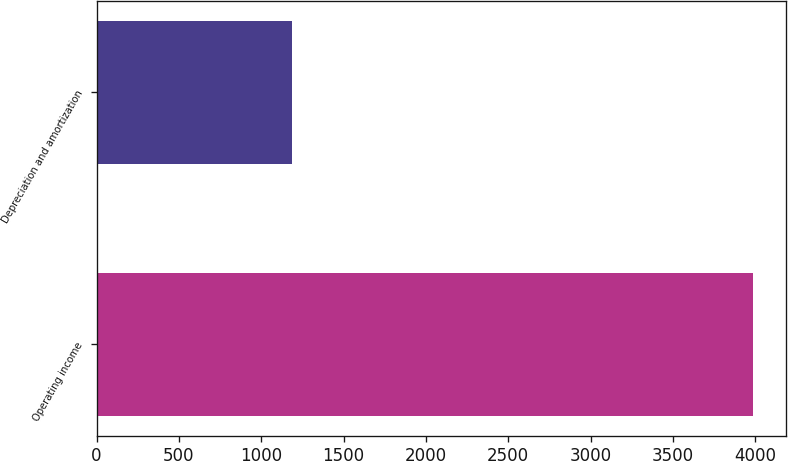Convert chart. <chart><loc_0><loc_0><loc_500><loc_500><bar_chart><fcel>Operating income<fcel>Depreciation and amortization<nl><fcel>3984<fcel>1187.6<nl></chart> 